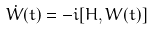<formula> <loc_0><loc_0><loc_500><loc_500>\dot { W } ( t ) = - i [ H , W ( t ) ]</formula> 